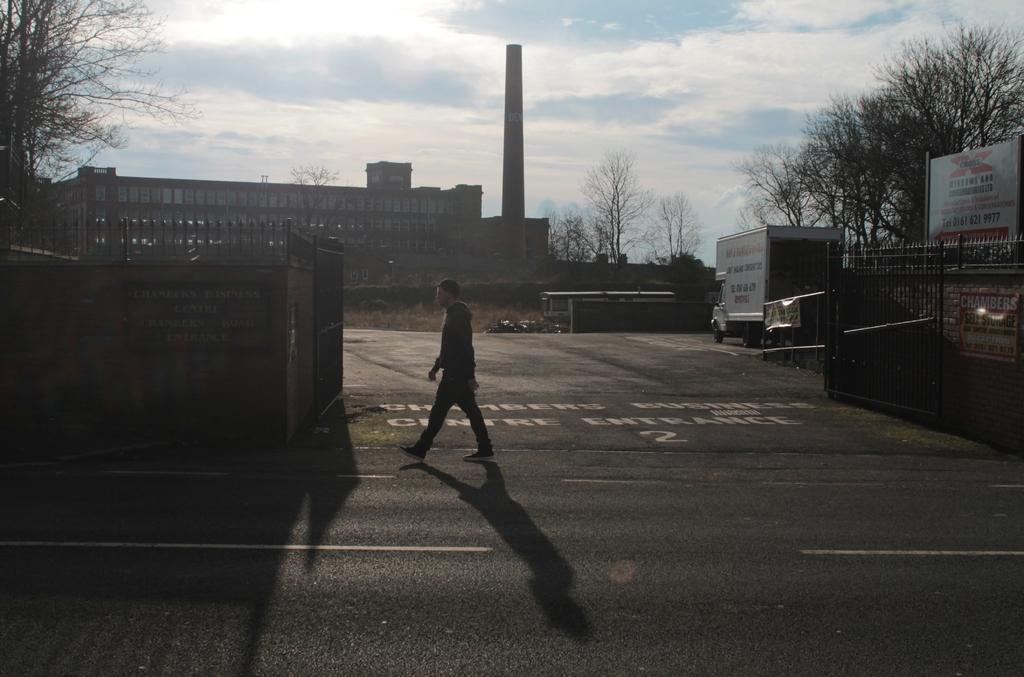Please provide a concise description of this image. In this image in the center there is a person walking and there is a wall and on the wall there is a board with some text written on it and there is a gate and on the top of the wall there is a fence. In the background there are trees, there is a building, there is a tower. On the right side there is a vehicle and there is a board with some text written on it and the sky is cloudy. 